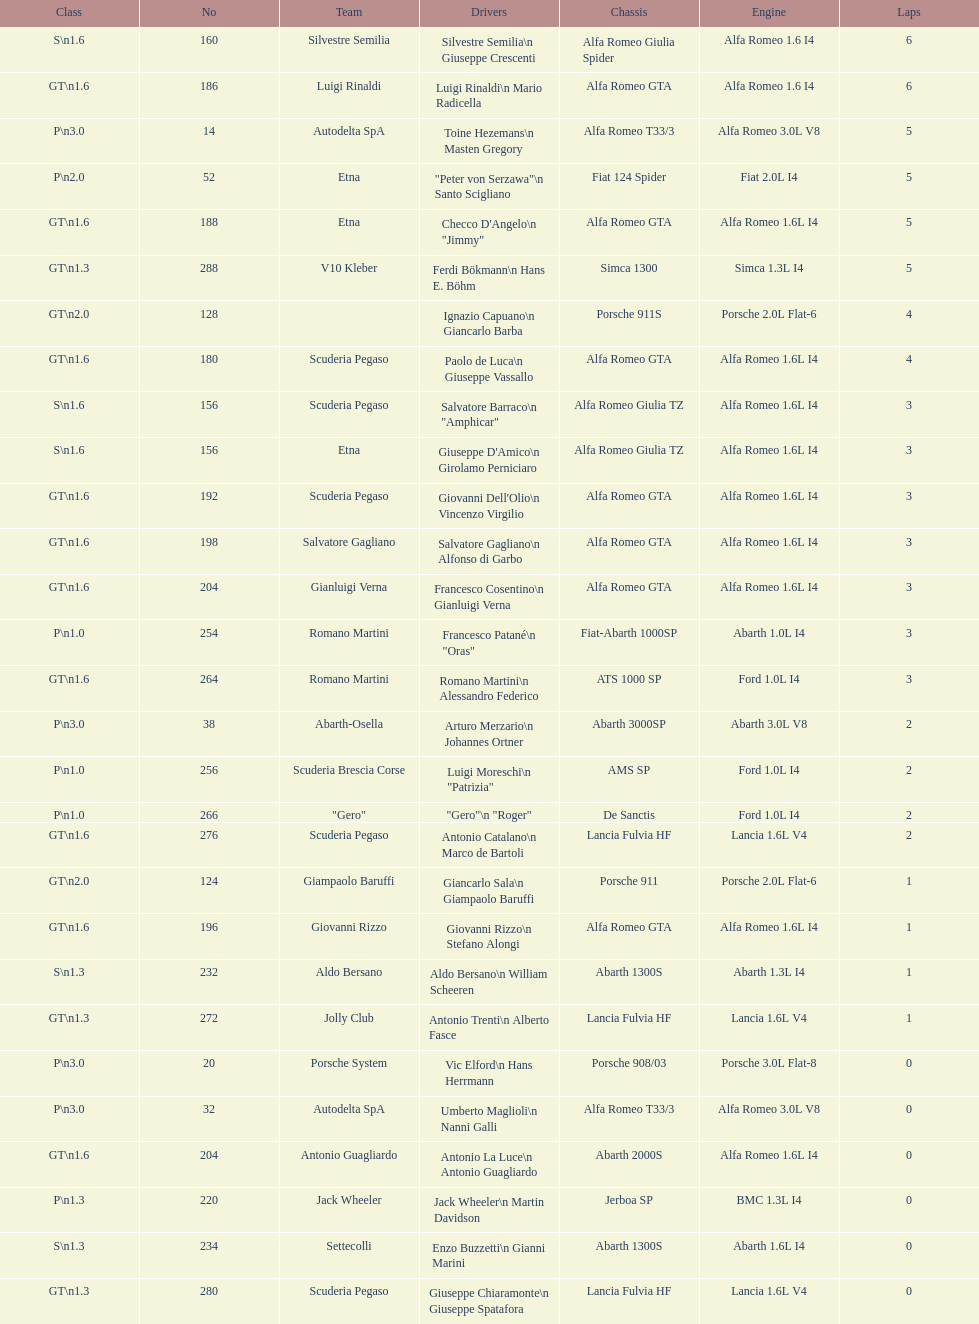Name the only american who did not finish the race. Masten Gregory. 